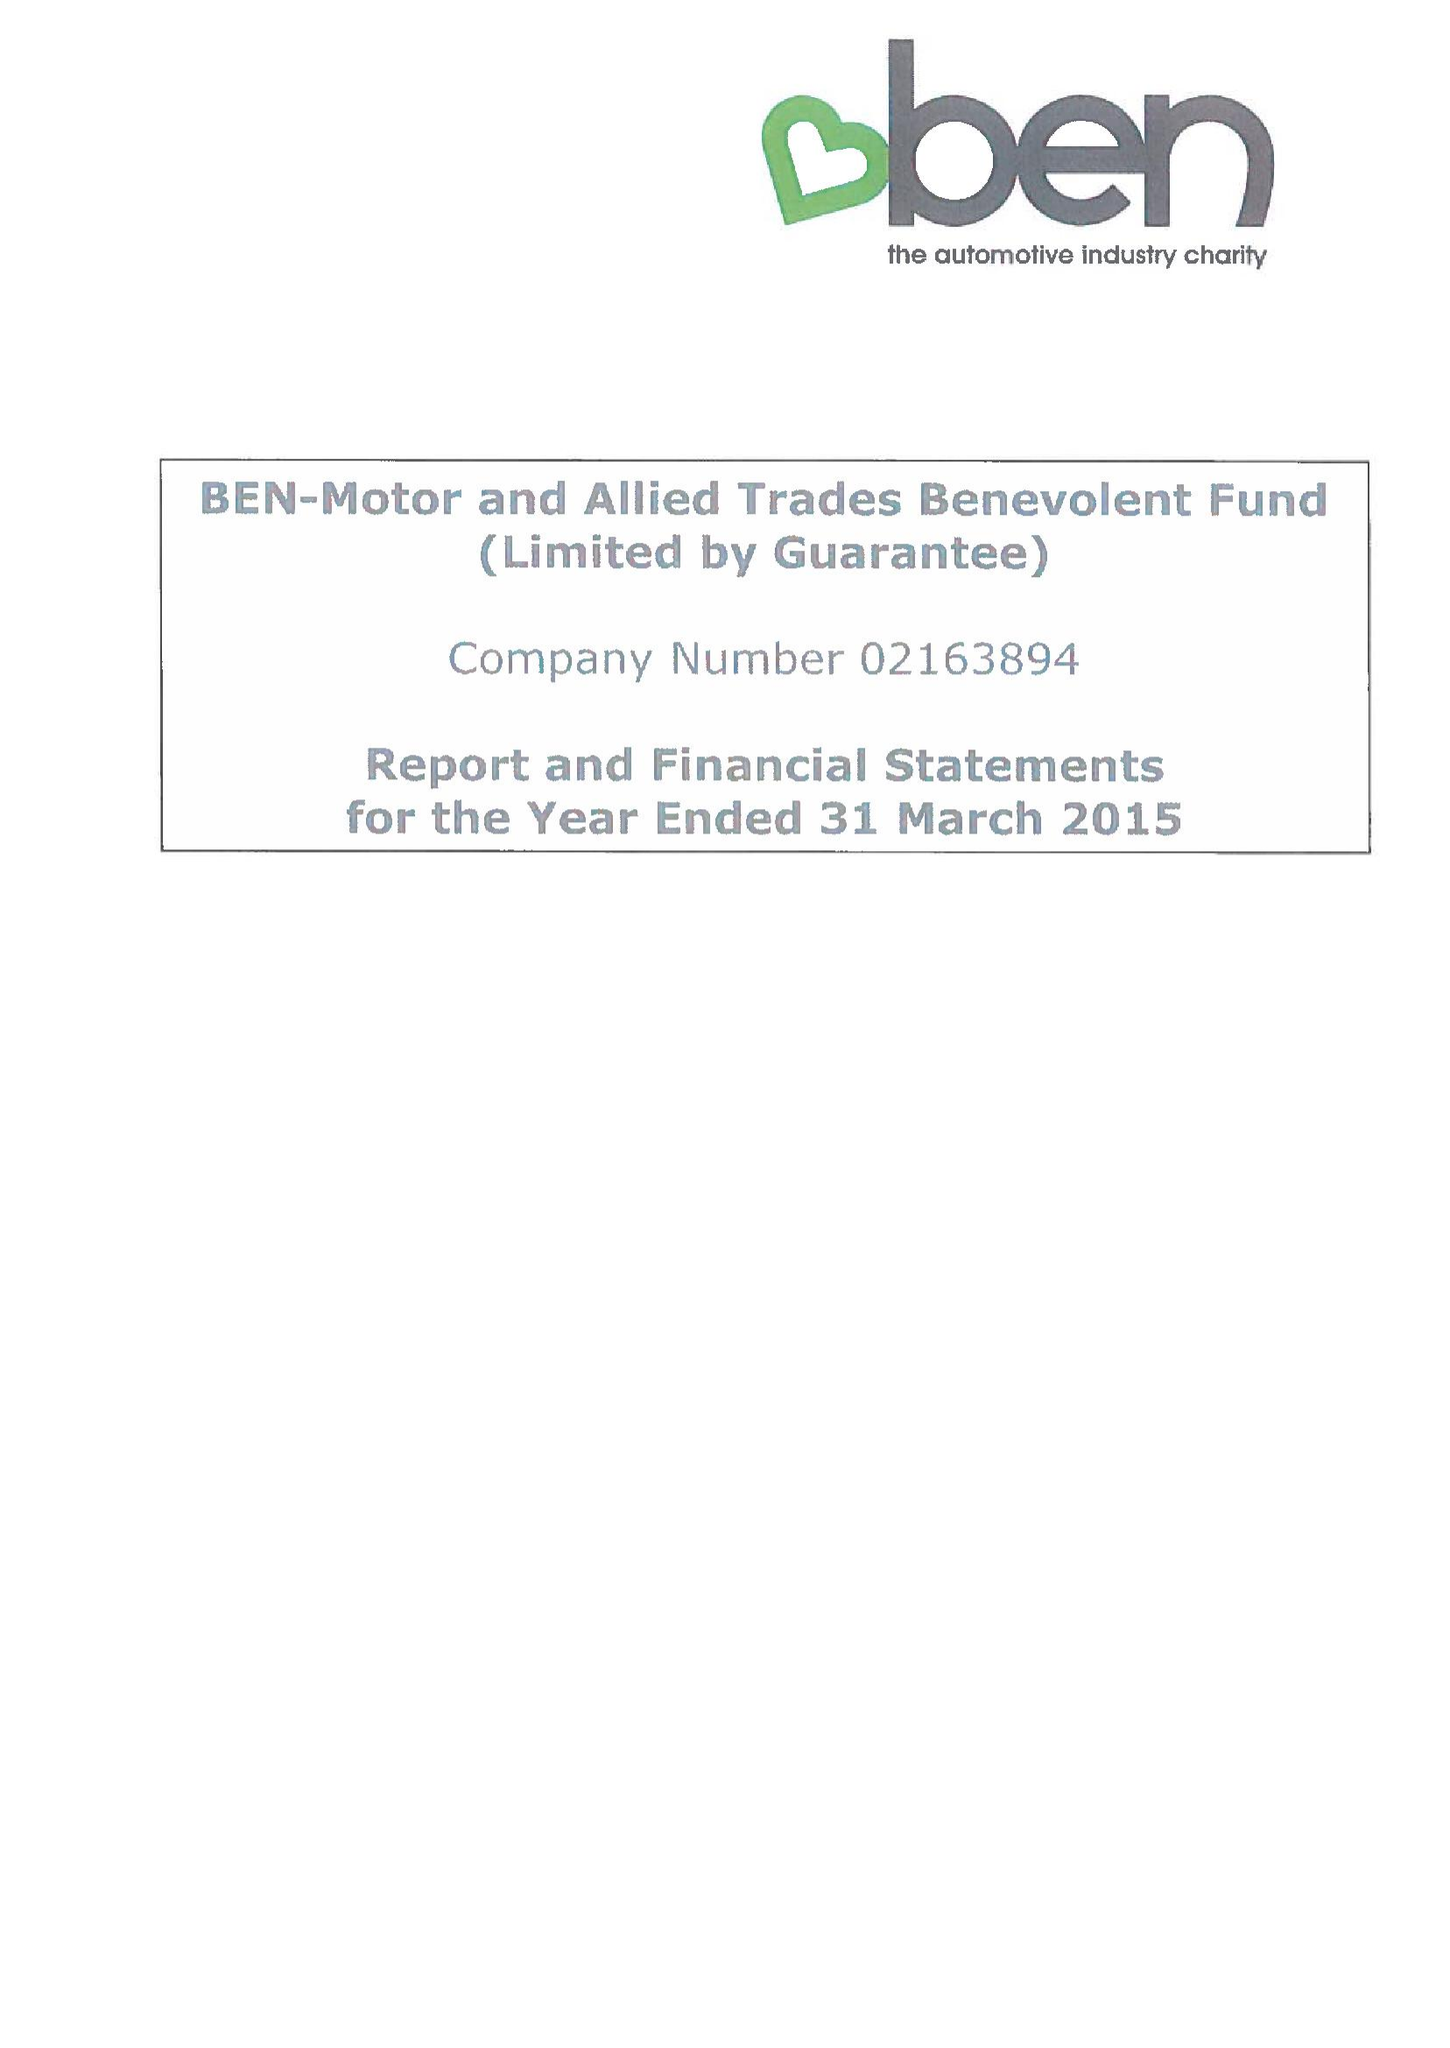What is the value for the address__post_town?
Answer the question using a single word or phrase. ASCOT 